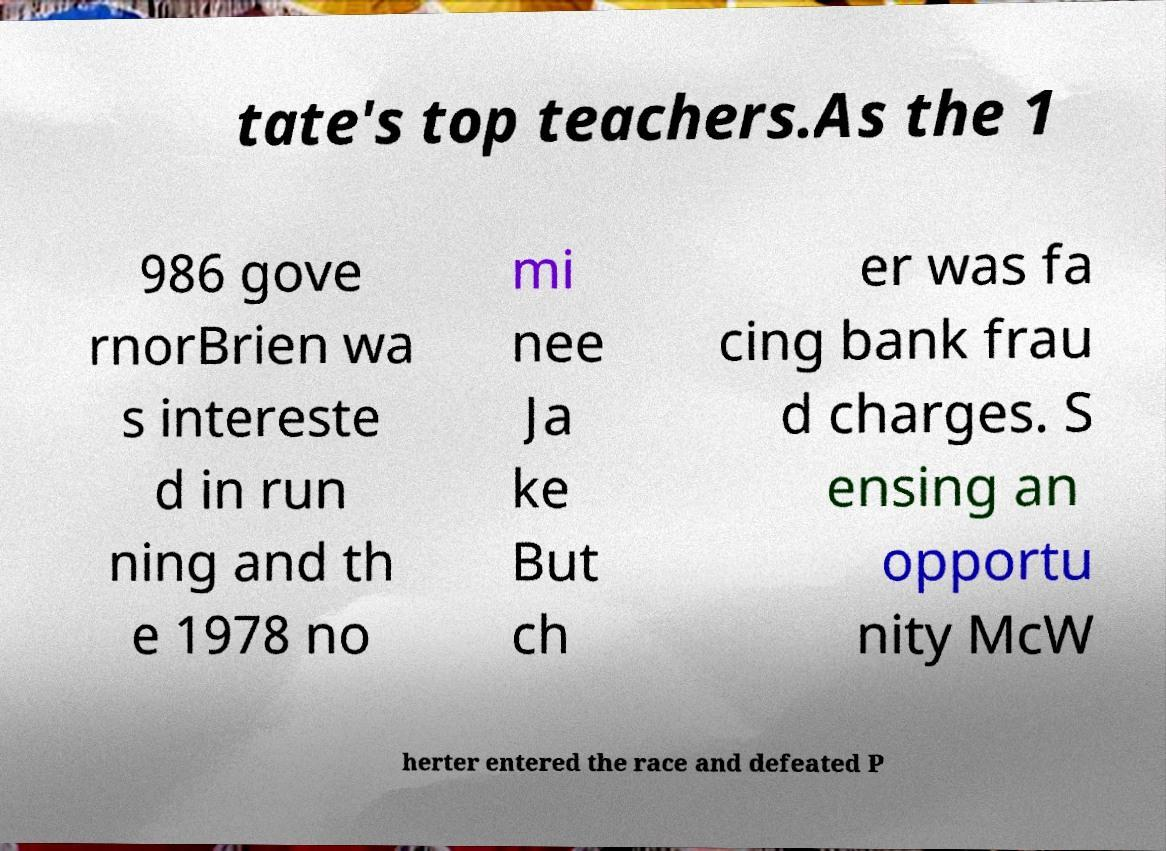For documentation purposes, I need the text within this image transcribed. Could you provide that? tate's top teachers.As the 1 986 gove rnorBrien wa s intereste d in run ning and th e 1978 no mi nee Ja ke But ch er was fa cing bank frau d charges. S ensing an opportu nity McW herter entered the race and defeated P 